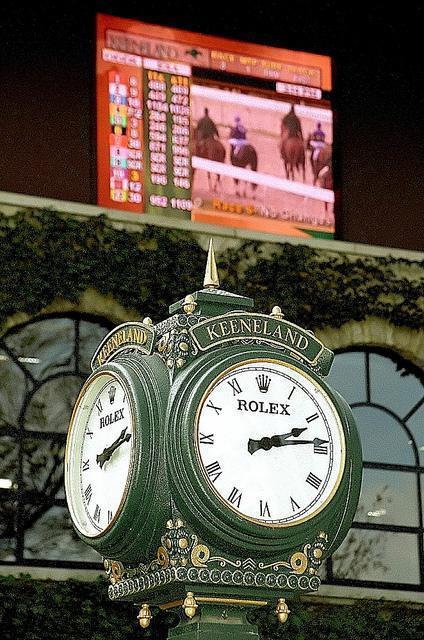How many clocks are shown?
Give a very brief answer. 2. How many clocks are visible?
Give a very brief answer. 2. How many rolls of toilet paper are there?
Give a very brief answer. 0. 